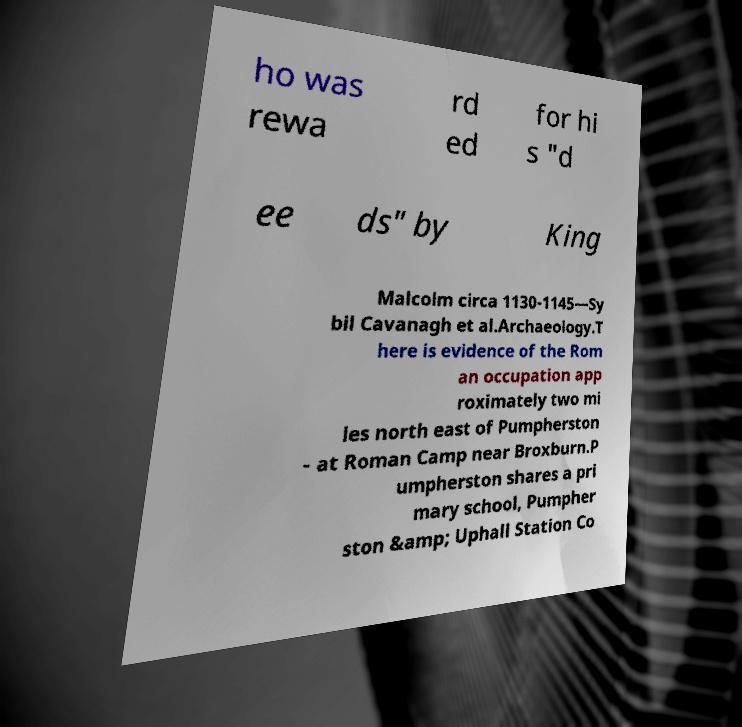For documentation purposes, I need the text within this image transcribed. Could you provide that? ho was rewa rd ed for hi s "d ee ds" by King Malcolm circa 1130-1145—Sy bil Cavanagh et al.Archaeology.T here is evidence of the Rom an occupation app roximately two mi les north east of Pumpherston - at Roman Camp near Broxburn.P umpherston shares a pri mary school, Pumpher ston &amp; Uphall Station Co 